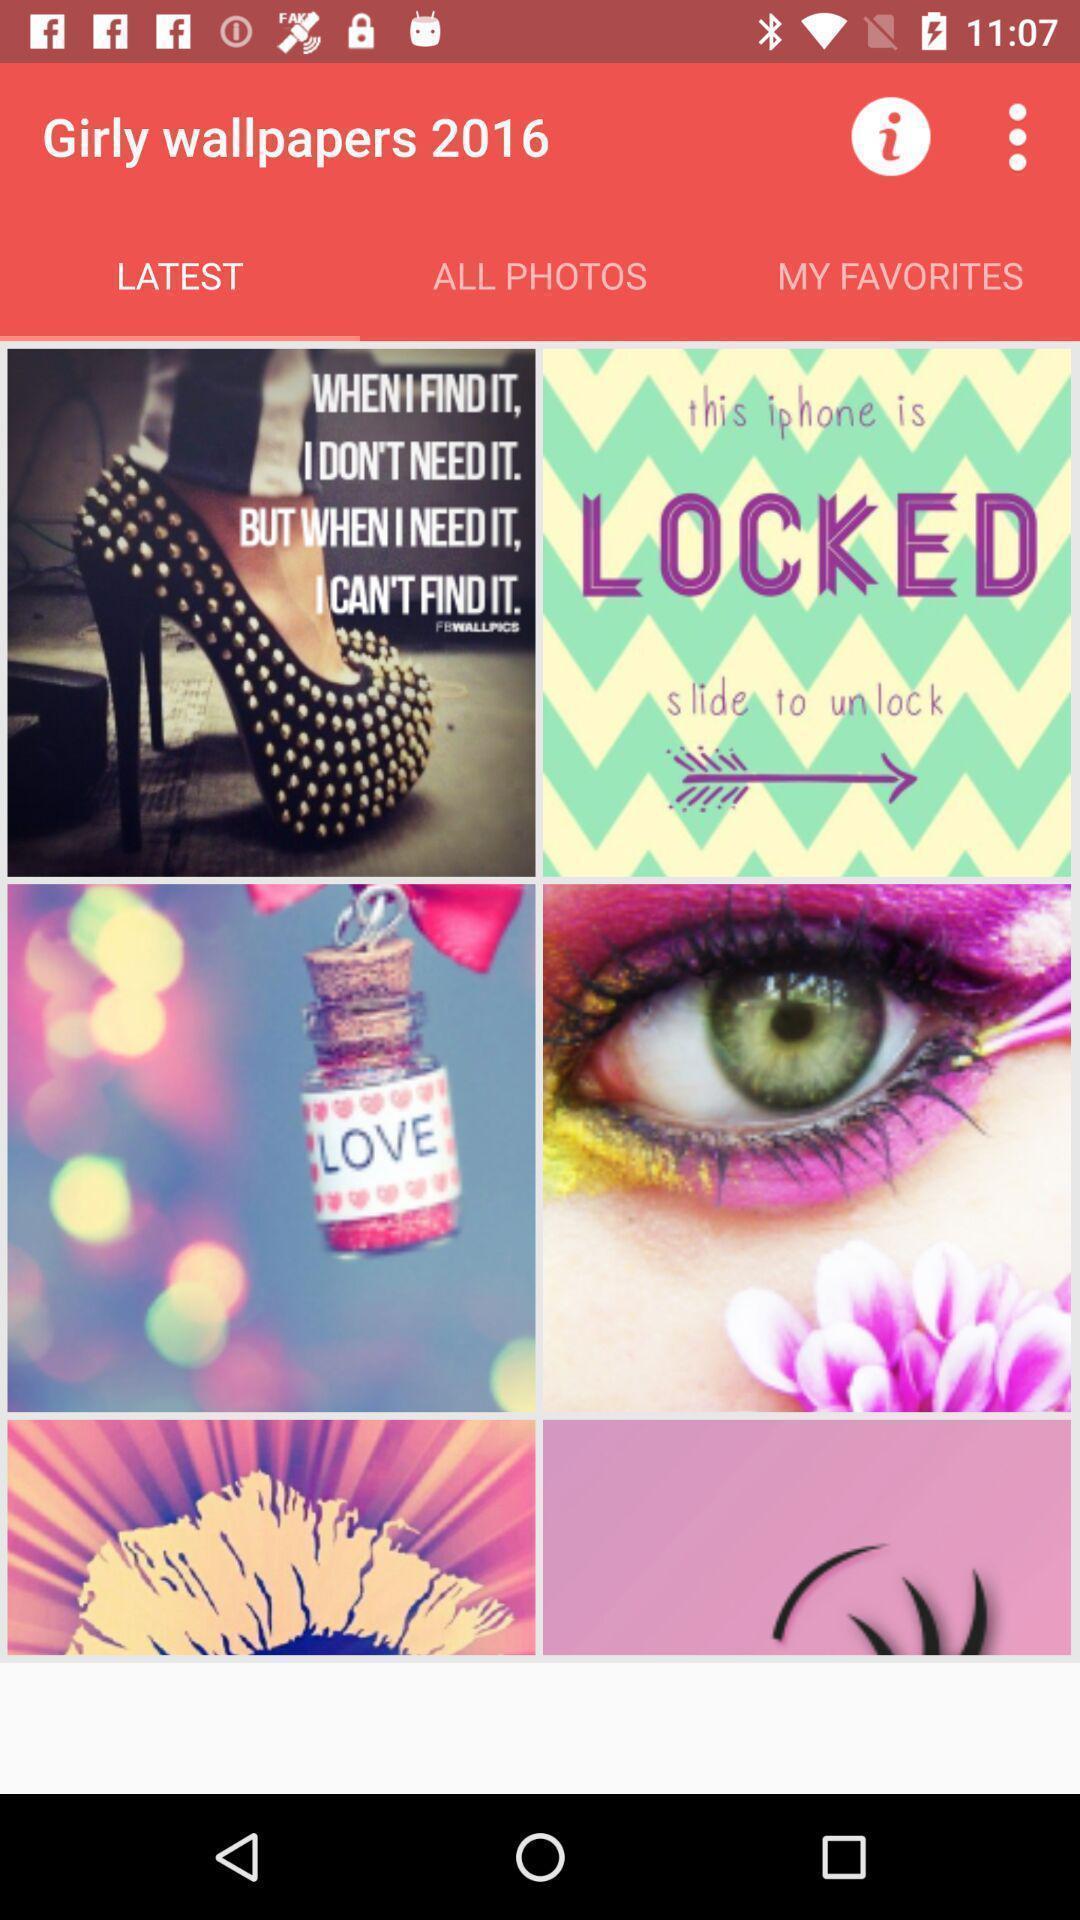Explain what's happening in this screen capture. Page showing list of wallpapers. 